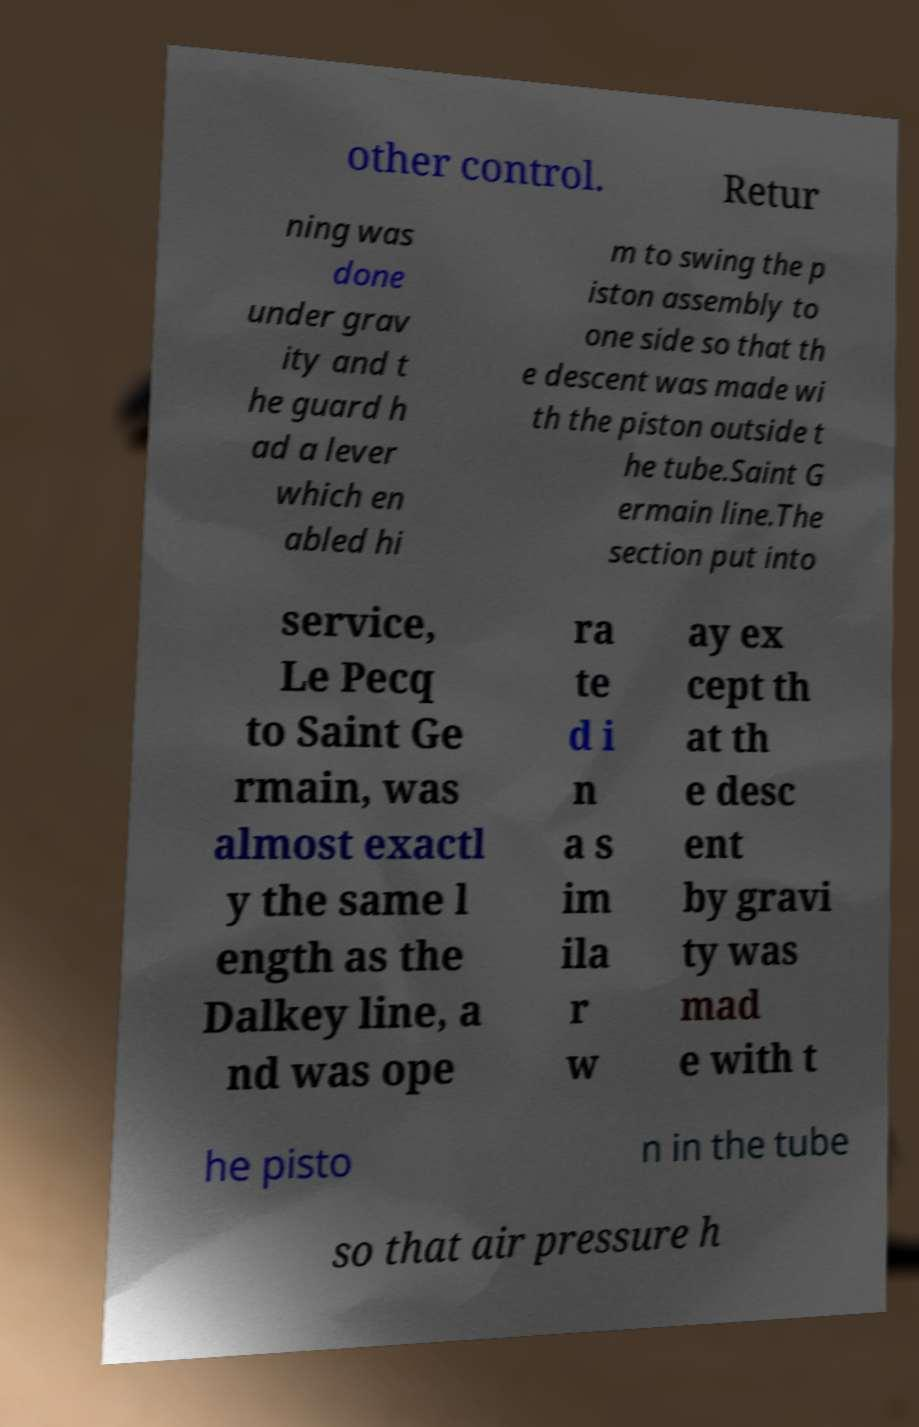Please read and relay the text visible in this image. What does it say? other control. Retur ning was done under grav ity and t he guard h ad a lever which en abled hi m to swing the p iston assembly to one side so that th e descent was made wi th the piston outside t he tube.Saint G ermain line.The section put into service, Le Pecq to Saint Ge rmain, was almost exactl y the same l ength as the Dalkey line, a nd was ope ra te d i n a s im ila r w ay ex cept th at th e desc ent by gravi ty was mad e with t he pisto n in the tube so that air pressure h 